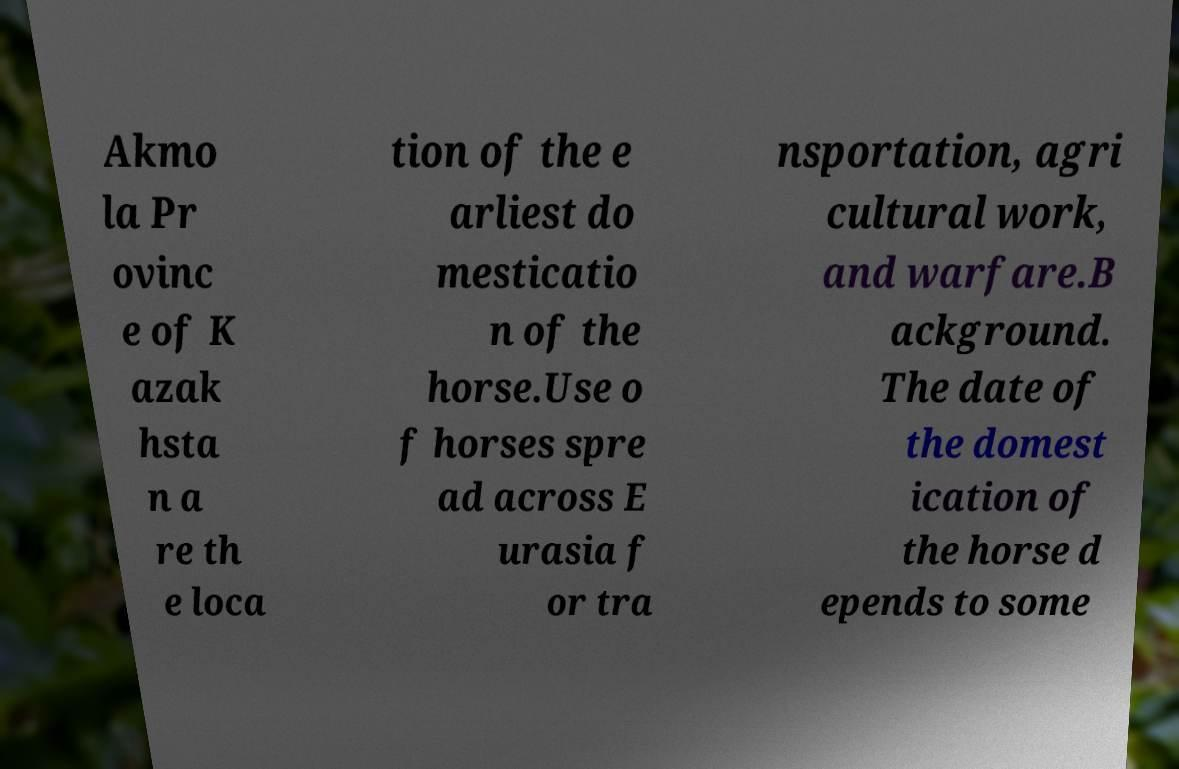There's text embedded in this image that I need extracted. Can you transcribe it verbatim? Akmo la Pr ovinc e of K azak hsta n a re th e loca tion of the e arliest do mesticatio n of the horse.Use o f horses spre ad across E urasia f or tra nsportation, agri cultural work, and warfare.B ackground. The date of the domest ication of the horse d epends to some 